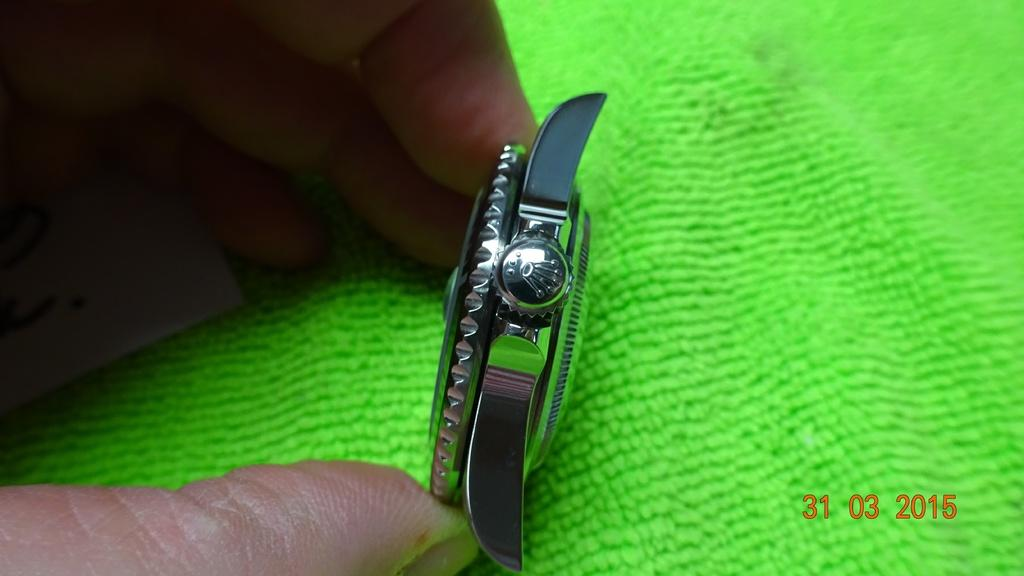What objects are in the person's hand in the image? There is a dial and crown in the person's hand in the image. What is the dial and crown placed on? The dial and crown are on a green color cloth. Can you see a toad hopping on the green cloth in the image? No, there is no toad present in the image. What type of soda is being poured from the dial and crown in the image? There is no soda being poured in the image; it features a dial and crown being held by a person's hand. 